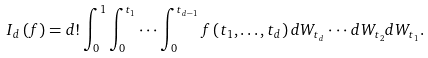Convert formula to latex. <formula><loc_0><loc_0><loc_500><loc_500>I _ { d } \left ( f \right ) = d ! \int _ { 0 } ^ { 1 } \int _ { 0 } ^ { t _ { 1 } } \cdot \cdot \cdot \int _ { 0 } ^ { t _ { d - 1 } } f \left ( t _ { 1 } , \dots , t _ { d } \right ) d W _ { t _ { d } } \cdot \cdot \cdot d W _ { t _ { 2 } } d W _ { t _ { 1 } } .</formula> 